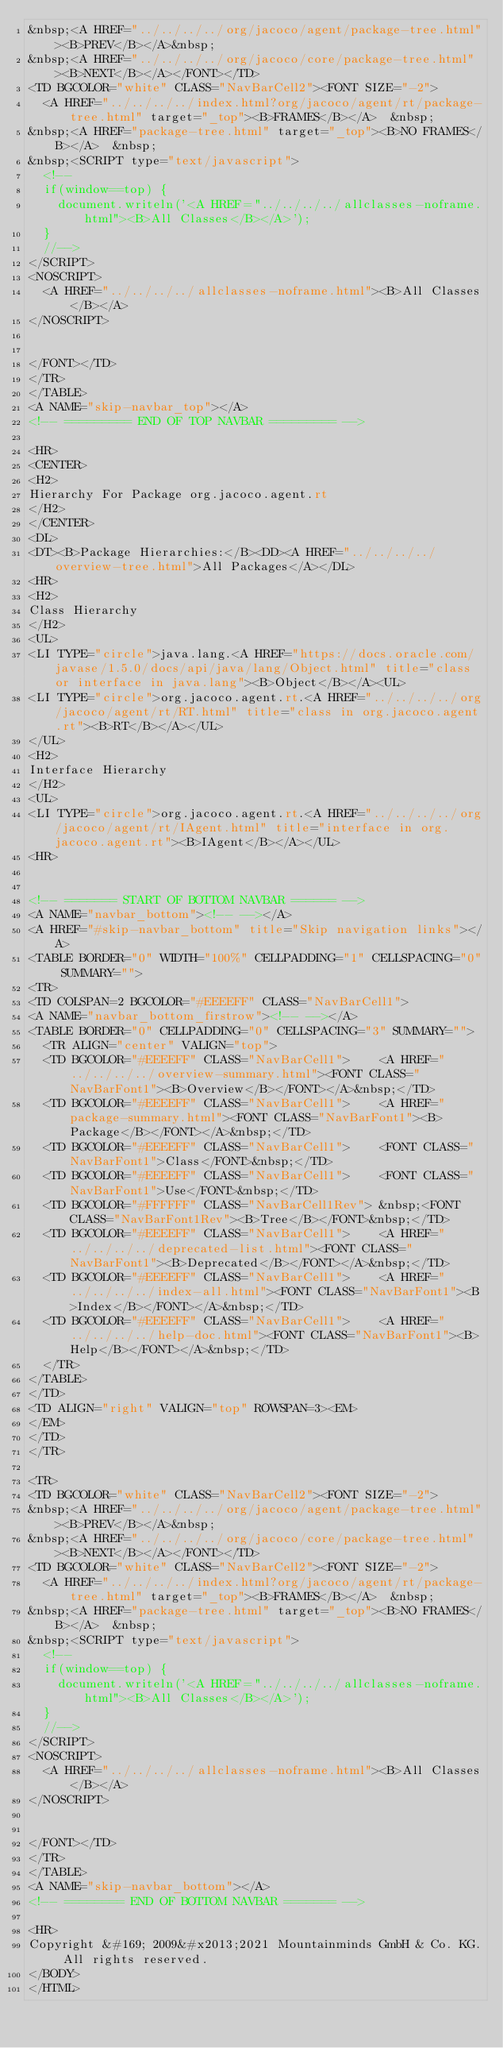<code> <loc_0><loc_0><loc_500><loc_500><_HTML_>&nbsp;<A HREF="../../../../org/jacoco/agent/package-tree.html"><B>PREV</B></A>&nbsp;
&nbsp;<A HREF="../../../../org/jacoco/core/package-tree.html"><B>NEXT</B></A></FONT></TD>
<TD BGCOLOR="white" CLASS="NavBarCell2"><FONT SIZE="-2">
  <A HREF="../../../../index.html?org/jacoco/agent/rt/package-tree.html" target="_top"><B>FRAMES</B></A>  &nbsp;
&nbsp;<A HREF="package-tree.html" target="_top"><B>NO FRAMES</B></A>  &nbsp;
&nbsp;<SCRIPT type="text/javascript">
  <!--
  if(window==top) {
    document.writeln('<A HREF="../../../../allclasses-noframe.html"><B>All Classes</B></A>');
  }
  //-->
</SCRIPT>
<NOSCRIPT>
  <A HREF="../../../../allclasses-noframe.html"><B>All Classes</B></A>
</NOSCRIPT>


</FONT></TD>
</TR>
</TABLE>
<A NAME="skip-navbar_top"></A>
<!-- ========= END OF TOP NAVBAR ========= -->

<HR>
<CENTER>
<H2>
Hierarchy For Package org.jacoco.agent.rt
</H2>
</CENTER>
<DL>
<DT><B>Package Hierarchies:</B><DD><A HREF="../../../../overview-tree.html">All Packages</A></DL>
<HR>
<H2>
Class Hierarchy
</H2>
<UL>
<LI TYPE="circle">java.lang.<A HREF="https://docs.oracle.com/javase/1.5.0/docs/api/java/lang/Object.html" title="class or interface in java.lang"><B>Object</B></A><UL>
<LI TYPE="circle">org.jacoco.agent.rt.<A HREF="../../../../org/jacoco/agent/rt/RT.html" title="class in org.jacoco.agent.rt"><B>RT</B></A></UL>
</UL>
<H2>
Interface Hierarchy
</H2>
<UL>
<LI TYPE="circle">org.jacoco.agent.rt.<A HREF="../../../../org/jacoco/agent/rt/IAgent.html" title="interface in org.jacoco.agent.rt"><B>IAgent</B></A></UL>
<HR>


<!-- ======= START OF BOTTOM NAVBAR ====== -->
<A NAME="navbar_bottom"><!-- --></A>
<A HREF="#skip-navbar_bottom" title="Skip navigation links"></A>
<TABLE BORDER="0" WIDTH="100%" CELLPADDING="1" CELLSPACING="0" SUMMARY="">
<TR>
<TD COLSPAN=2 BGCOLOR="#EEEEFF" CLASS="NavBarCell1">
<A NAME="navbar_bottom_firstrow"><!-- --></A>
<TABLE BORDER="0" CELLPADDING="0" CELLSPACING="3" SUMMARY="">
  <TR ALIGN="center" VALIGN="top">
  <TD BGCOLOR="#EEEEFF" CLASS="NavBarCell1">    <A HREF="../../../../overview-summary.html"><FONT CLASS="NavBarFont1"><B>Overview</B></FONT></A>&nbsp;</TD>
  <TD BGCOLOR="#EEEEFF" CLASS="NavBarCell1">    <A HREF="package-summary.html"><FONT CLASS="NavBarFont1"><B>Package</B></FONT></A>&nbsp;</TD>
  <TD BGCOLOR="#EEEEFF" CLASS="NavBarCell1">    <FONT CLASS="NavBarFont1">Class</FONT>&nbsp;</TD>
  <TD BGCOLOR="#EEEEFF" CLASS="NavBarCell1">    <FONT CLASS="NavBarFont1">Use</FONT>&nbsp;</TD>
  <TD BGCOLOR="#FFFFFF" CLASS="NavBarCell1Rev"> &nbsp;<FONT CLASS="NavBarFont1Rev"><B>Tree</B></FONT>&nbsp;</TD>
  <TD BGCOLOR="#EEEEFF" CLASS="NavBarCell1">    <A HREF="../../../../deprecated-list.html"><FONT CLASS="NavBarFont1"><B>Deprecated</B></FONT></A>&nbsp;</TD>
  <TD BGCOLOR="#EEEEFF" CLASS="NavBarCell1">    <A HREF="../../../../index-all.html"><FONT CLASS="NavBarFont1"><B>Index</B></FONT></A>&nbsp;</TD>
  <TD BGCOLOR="#EEEEFF" CLASS="NavBarCell1">    <A HREF="../../../../help-doc.html"><FONT CLASS="NavBarFont1"><B>Help</B></FONT></A>&nbsp;</TD>
  </TR>
</TABLE>
</TD>
<TD ALIGN="right" VALIGN="top" ROWSPAN=3><EM>
</EM>
</TD>
</TR>

<TR>
<TD BGCOLOR="white" CLASS="NavBarCell2"><FONT SIZE="-2">
&nbsp;<A HREF="../../../../org/jacoco/agent/package-tree.html"><B>PREV</B></A>&nbsp;
&nbsp;<A HREF="../../../../org/jacoco/core/package-tree.html"><B>NEXT</B></A></FONT></TD>
<TD BGCOLOR="white" CLASS="NavBarCell2"><FONT SIZE="-2">
  <A HREF="../../../../index.html?org/jacoco/agent/rt/package-tree.html" target="_top"><B>FRAMES</B></A>  &nbsp;
&nbsp;<A HREF="package-tree.html" target="_top"><B>NO FRAMES</B></A>  &nbsp;
&nbsp;<SCRIPT type="text/javascript">
  <!--
  if(window==top) {
    document.writeln('<A HREF="../../../../allclasses-noframe.html"><B>All Classes</B></A>');
  }
  //-->
</SCRIPT>
<NOSCRIPT>
  <A HREF="../../../../allclasses-noframe.html"><B>All Classes</B></A>
</NOSCRIPT>


</FONT></TD>
</TR>
</TABLE>
<A NAME="skip-navbar_bottom"></A>
<!-- ======== END OF BOTTOM NAVBAR ======= -->

<HR>
Copyright &#169; 2009&#x2013;2021 Mountainminds GmbH & Co. KG. All rights reserved.
</BODY>
</HTML>
</code> 